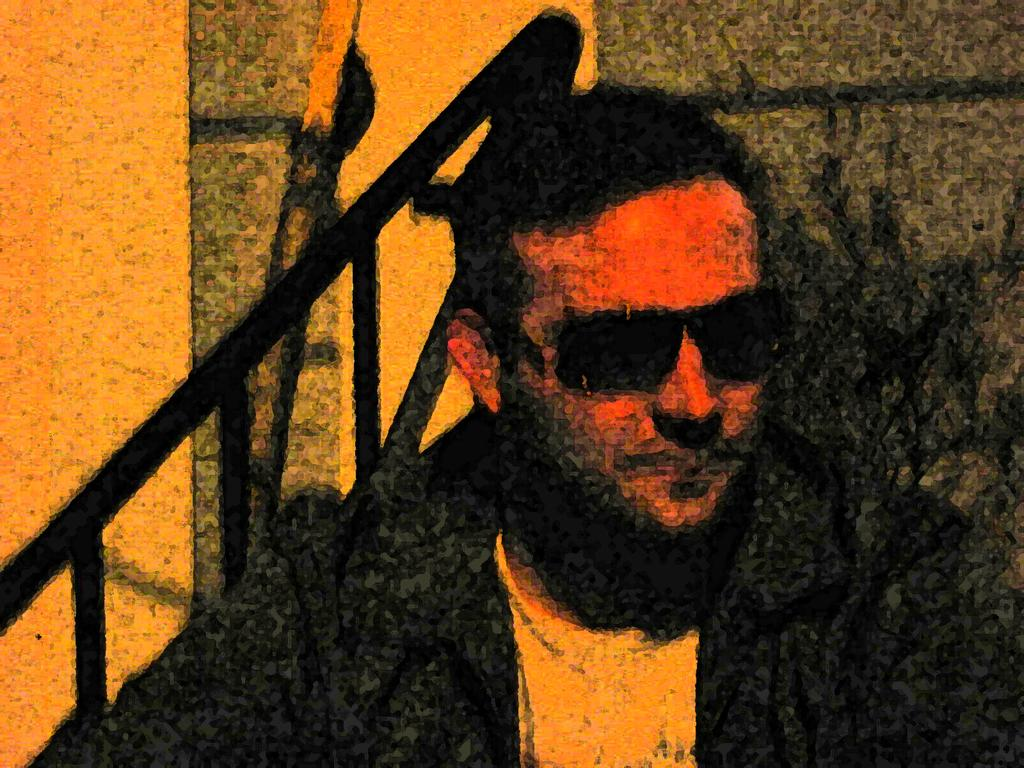What type of picture is shown in the image? The image is an edited picture. Can you describe the person in the image? There is a person in the image, and they are wearing goggles. What can be seen in the background of the image? There is a wall and a few rods in the background of the image. How many matches are visible in the image? There are no matches present in the image. What condition are the children in within the image? There are no children present in the image. 